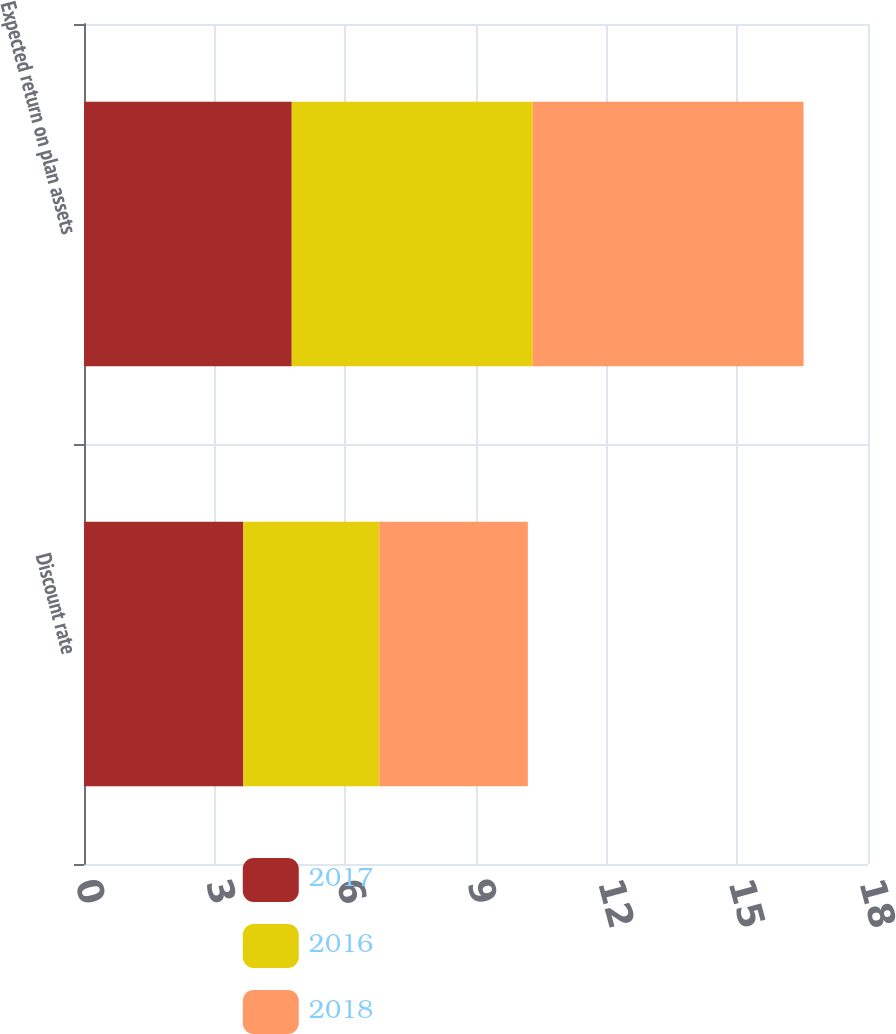Convert chart to OTSL. <chart><loc_0><loc_0><loc_500><loc_500><stacked_bar_chart><ecel><fcel>Discount rate<fcel>Expected return on plan assets<nl><fcel>2017<fcel>3.66<fcel>4.77<nl><fcel>2016<fcel>3.12<fcel>5.53<nl><fcel>2018<fcel>3.41<fcel>6.22<nl></chart> 